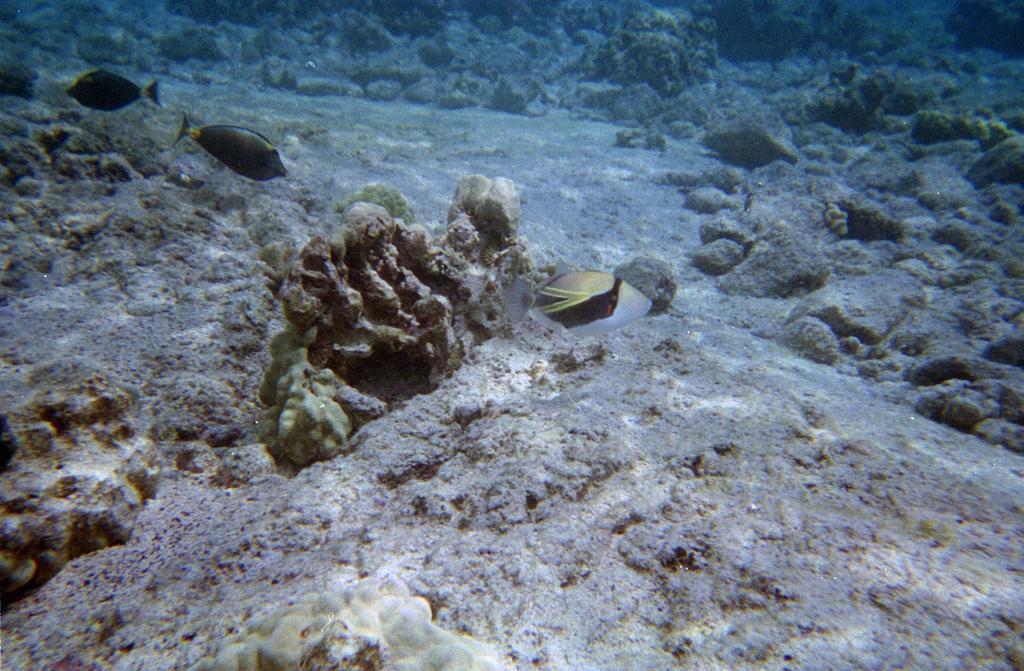How would you summarize this image in a sentence or two? In this image I can see few fishes in multicolor. I can see water and few stones. 